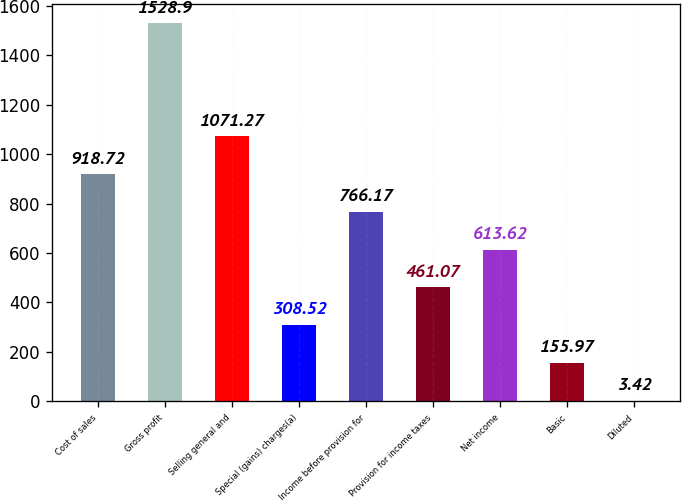Convert chart. <chart><loc_0><loc_0><loc_500><loc_500><bar_chart><fcel>Cost of sales<fcel>Gross profit<fcel>Selling general and<fcel>Special (gains) charges(a)<fcel>Income before provision for<fcel>Provision for income taxes<fcel>Net income<fcel>Basic<fcel>Diluted<nl><fcel>918.72<fcel>1528.9<fcel>1071.27<fcel>308.52<fcel>766.17<fcel>461.07<fcel>613.62<fcel>155.97<fcel>3.42<nl></chart> 